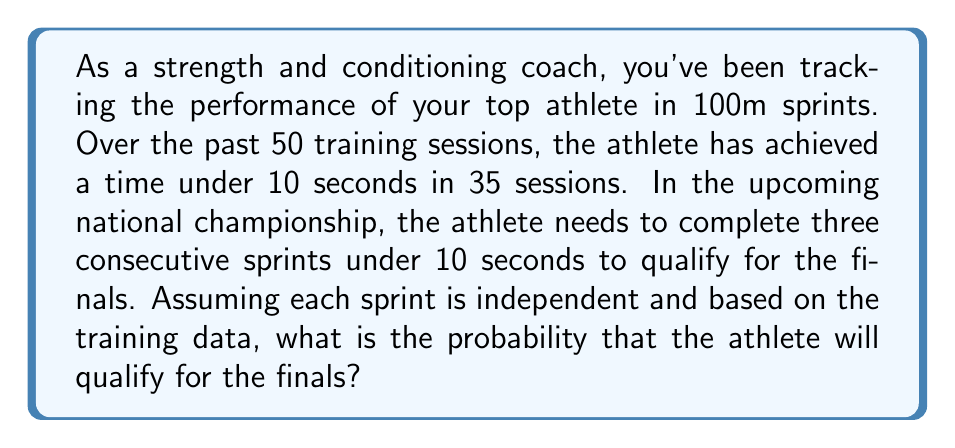Show me your answer to this math problem. Let's approach this step-by-step:

1) First, we need to calculate the probability of the athlete running a single sprint under 10 seconds based on the training data:

   $P(\text{sprint under 10s}) = \frac{\text{successful attempts}}{\text{total attempts}} = \frac{35}{50} = 0.7$

2) Now, we need to calculate the probability of achieving this three times in a row. Since each sprint is assumed to be independent, we can use the multiplication rule of probability:

   $P(\text{3 consecutive sprints under 10s}) = P(\text{sprint 1 under 10s}) \times P(\text{sprint 2 under 10s}) \times P(\text{sprint 3 under 10s})$

3) Substituting our probability from step 1:

   $P(\text{3 consecutive sprints under 10s}) = 0.7 \times 0.7 \times 0.7 = 0.7^3$

4) Calculate the final probability:

   $0.7^3 = 0.343 = 34.3\%$

Therefore, based on the training data, the probability that the athlete will qualify for the finals by completing three consecutive sprints under 10 seconds is approximately 0.343 or 34.3%.
Answer: $0.343$ or $34.3\%$ 